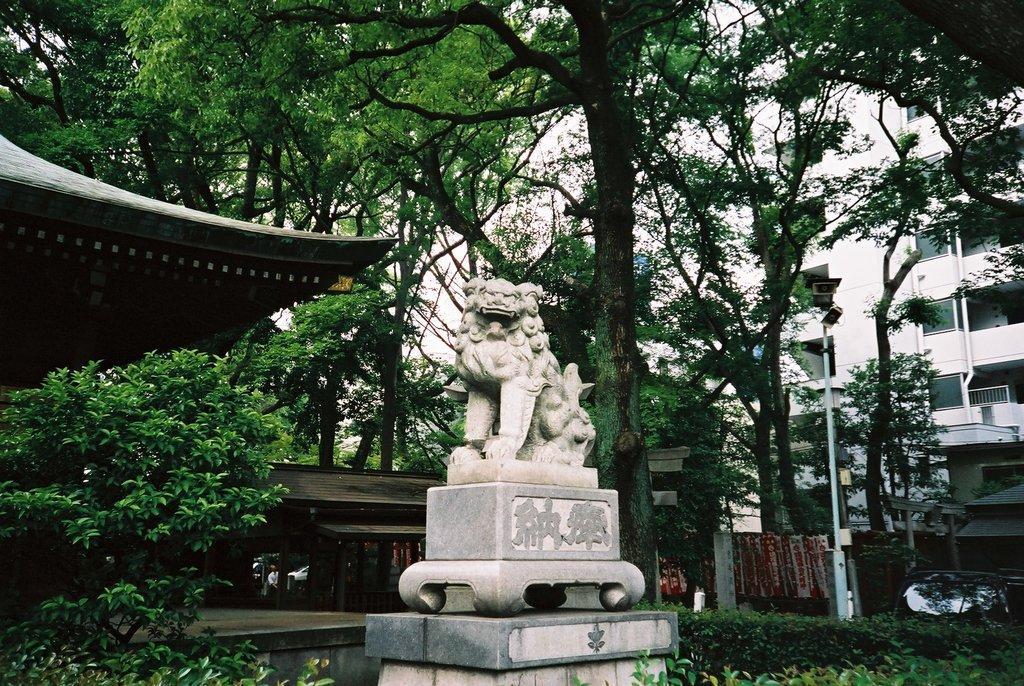Describe this image in one or two sentences. In this image we can see a statue and there are some trees and plants and we can see a building in the background. There is a structure which looks like a hut on the left side of the image and there is a wooden house behind the statue and we can see a street light. 